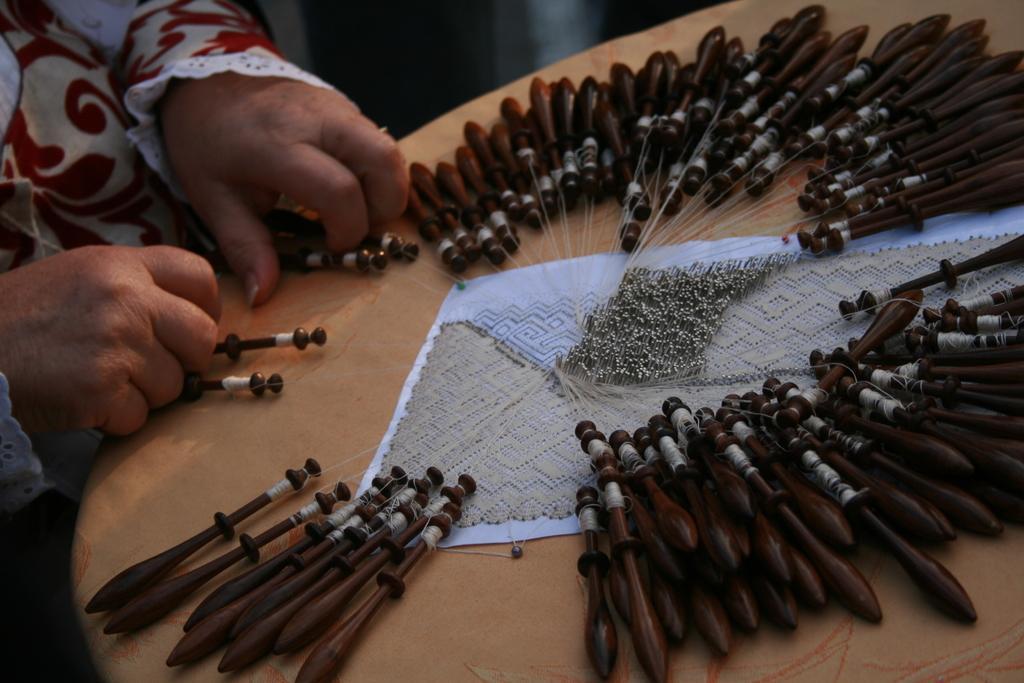In one or two sentences, can you explain what this image depicts? In this image there is a person truncated towards the left of the image, there is a table truncated towards the bottom of the image, there are objects on the table, there is a cloth on the table, there are objects truncated towards the right of the image, there is a cloth truncated towards the right of the image. 